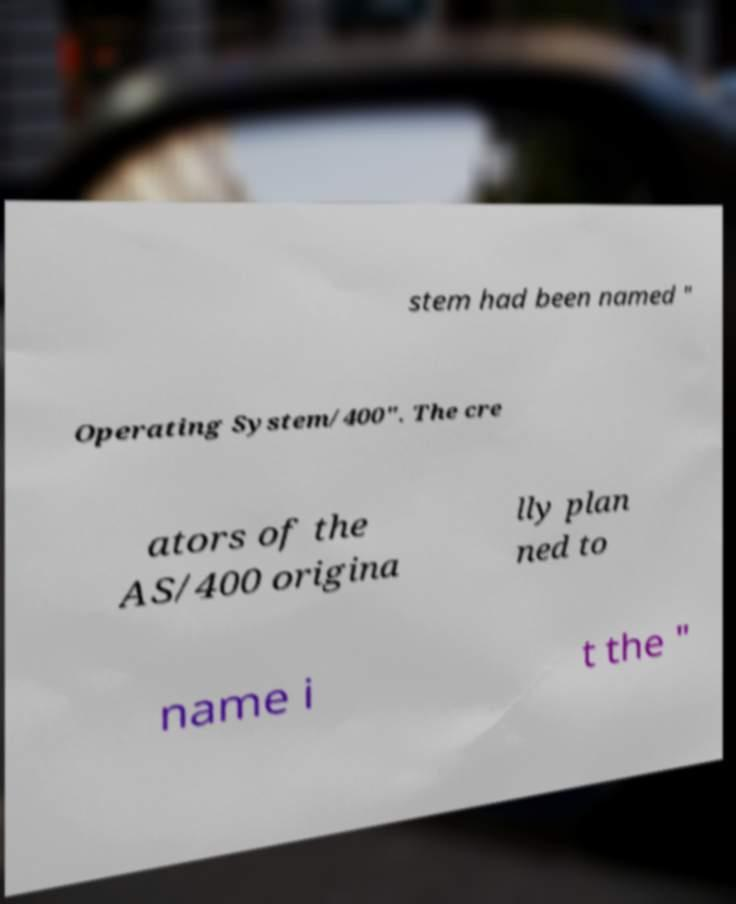For documentation purposes, I need the text within this image transcribed. Could you provide that? stem had been named " Operating System/400". The cre ators of the AS/400 origina lly plan ned to name i t the " 